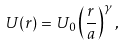Convert formula to latex. <formula><loc_0><loc_0><loc_500><loc_500>U ( r ) = U _ { 0 } \left ( \frac { r } { a } \right ) ^ { \gamma } ,</formula> 